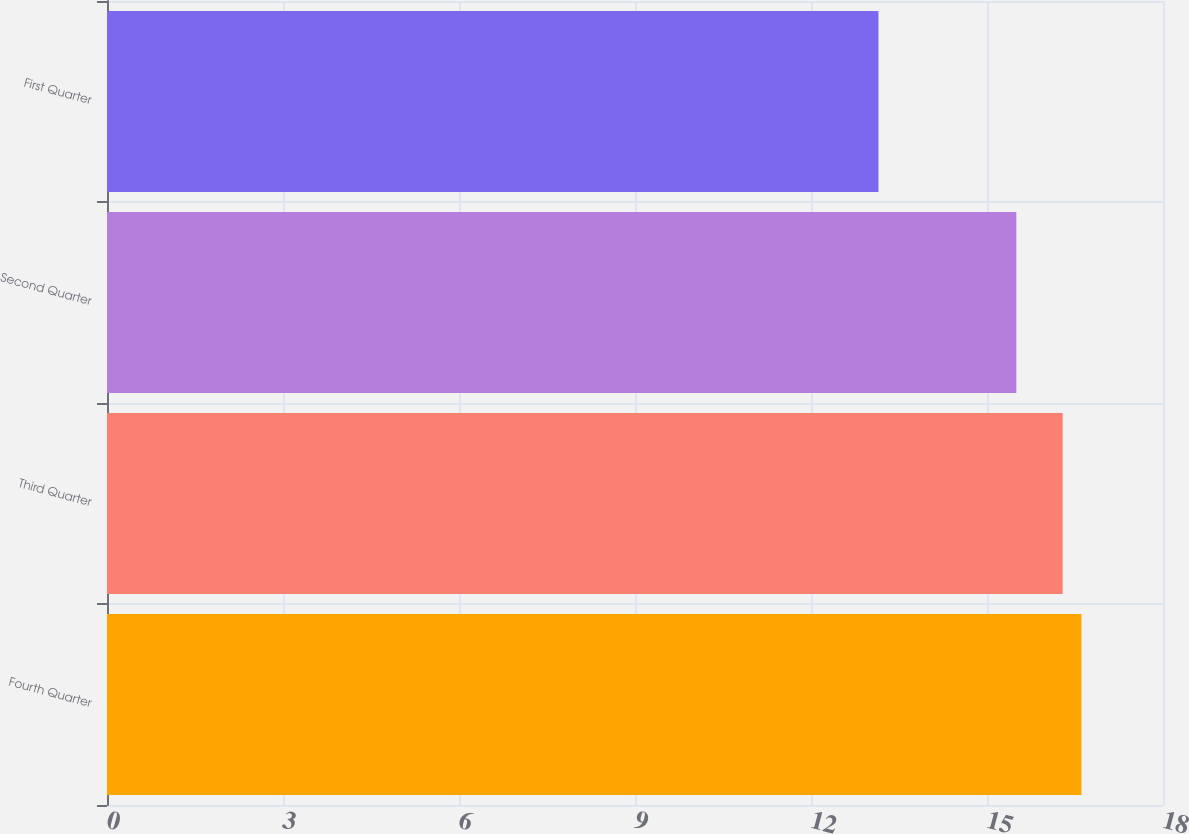Convert chart. <chart><loc_0><loc_0><loc_500><loc_500><bar_chart><fcel>Fourth Quarter<fcel>Third Quarter<fcel>Second Quarter<fcel>First Quarter<nl><fcel>16.61<fcel>16.29<fcel>15.5<fcel>13.15<nl></chart> 